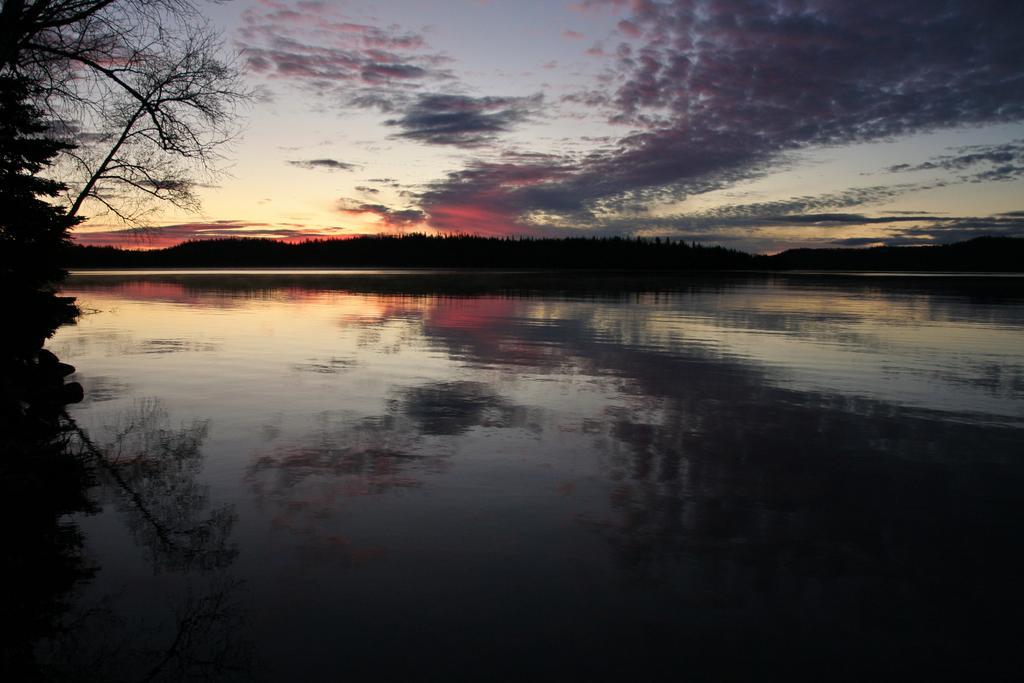Could you give a brief overview of what you see in this image? In this image there is the sky towards the top of the image, there are clouds in the sky, there are trees, there is water towards the bottom of the image, there is a tree towards the left of the image. 